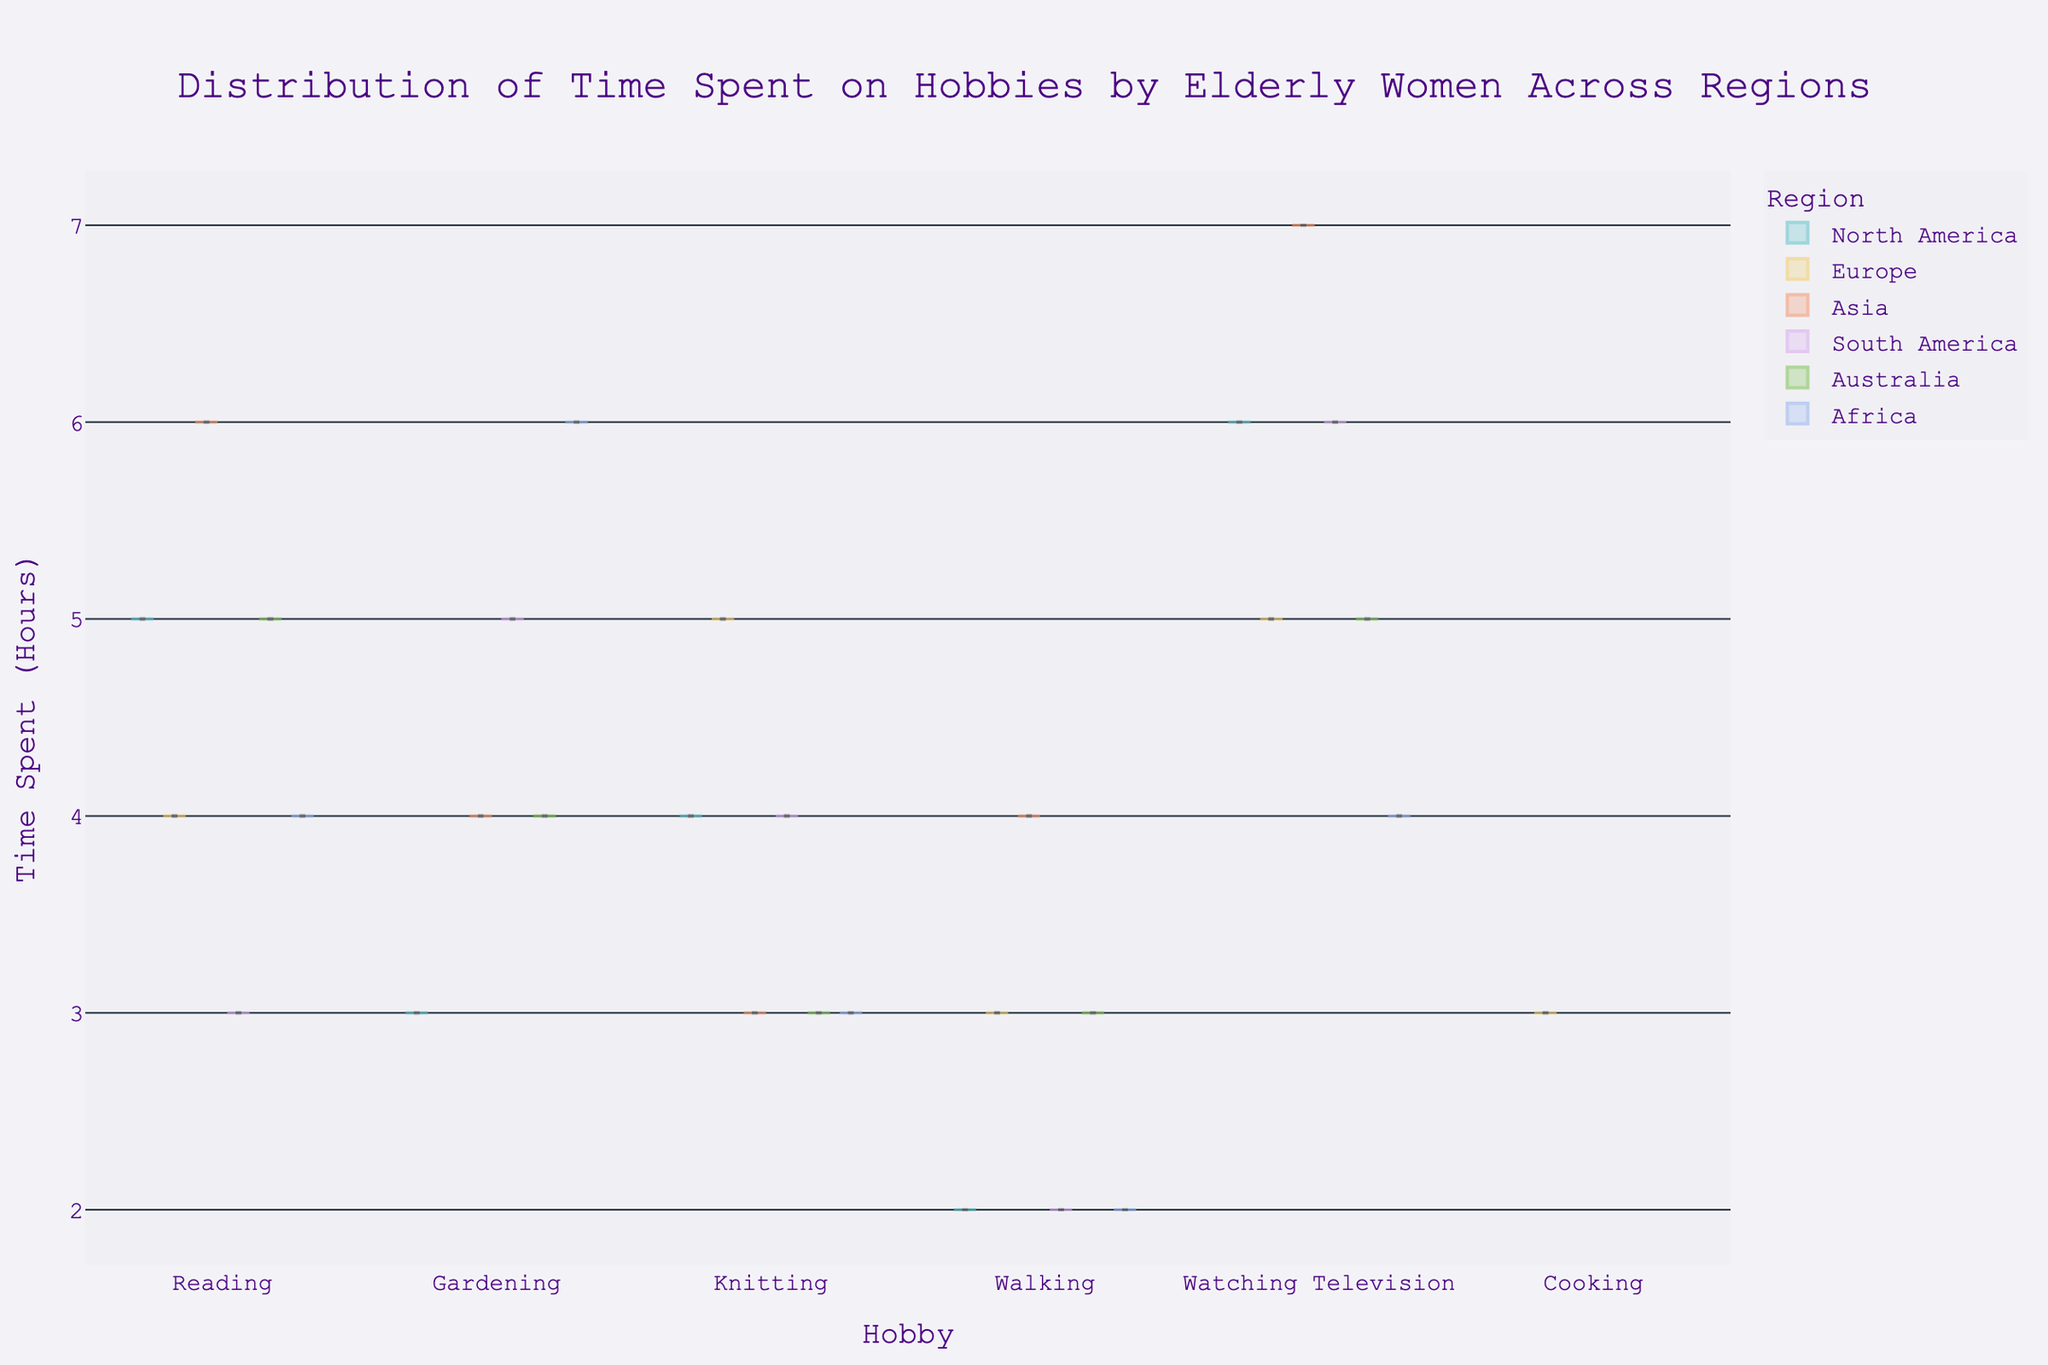Which region spends the most time on reading? Look at the highest point in the violin plot for the "Reading" hobby, identifying which region reaches the maximum value on the y-axis. The highest point for reading is in Asia.
Answer: Asia What is the median time spent on watching television in South America? Find the box plot within the violin chart for "Watching Television" under the South America region. The median is marked by the line inside the box. For South America, the median value is 6 hours.
Answer: 6 In which region do women spend the least amount of time on gardening? Observe the box and violin plots for "Gardening" and identify the lowest point across all regions. North America shows the least time spent on gardening with the minimum value at 3 hours.
Answer: North America Compare the median time spent on reading between North America and Europe. Which region spends more time? Find the median values in the box plot for "Reading" for both North America and Europe. Compare these values side by side. North America has a median of 5 hours, while Europe has 4 hours. Therefore, North America spends more time.
Answer: North America What is the range of time spent on knitting in Asia? Locate the violin plot for "Knitting" in Asia and identify the minimum and maximum values on the y-axis. The range is the difference between these two values. The minimum is 3 and the maximum is 7 hours. Therefore, the range is 7 - 3 = 4 hours.
Answer: 4 Which hobby shows the most consistent amount of time spent across all regions? Look for the hobby where the box plots show the least variation and are approximately the same size across all regions. Walking exhibits this consistency in the plot.
Answer: Walking How does the distribution of time spent on personal interests in Australia for walking compare to Africa? Compare the violin plots and box plots for "Walking" in both Australia and Africa. Look for the shape and spread of the data. Both regions show a median of 3 hours, but Australia's spread is slightly more uniform.
Answer: Similar, Australia slightly more uniform For which hobby is the maximum time spent higher in Europe compared to North America? Check the plots for each hobby and compare the maximum values in the violin plots between Europe and North America. For Knitting, Europe has a maximum of 5 hours, while North America has 4 hours.
Answer: Knitting What is the average time spent on cooking in Europe? Identify the data distribution for "Cooking" in Europe. Since the exact times are not visible in the provided format, consider the peak and the central tendencies along with the box plot's median, typically reflecting the average. The calculated median in the plot shows approximately 3 hours.
Answer: 3 hours 